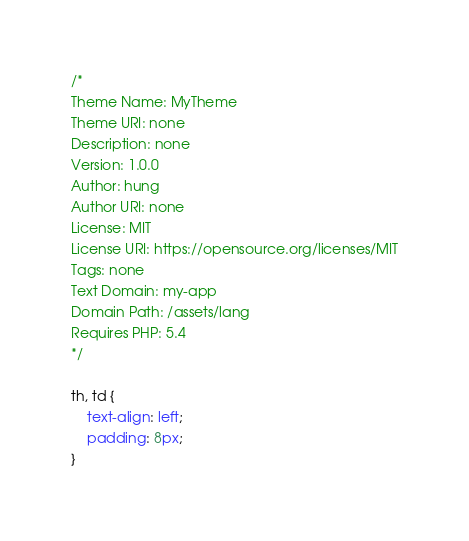<code> <loc_0><loc_0><loc_500><loc_500><_CSS_>/*
Theme Name: MyTheme
Theme URI: none
Description: none
Version: 1.0.0
Author: hung
Author URI: none
License: MIT
License URI: https://opensource.org/licenses/MIT
Tags: none
Text Domain: my-app
Domain Path: /assets/lang
Requires PHP: 5.4
*/

th, td {
    text-align: left;
    padding: 8px;
}</code> 